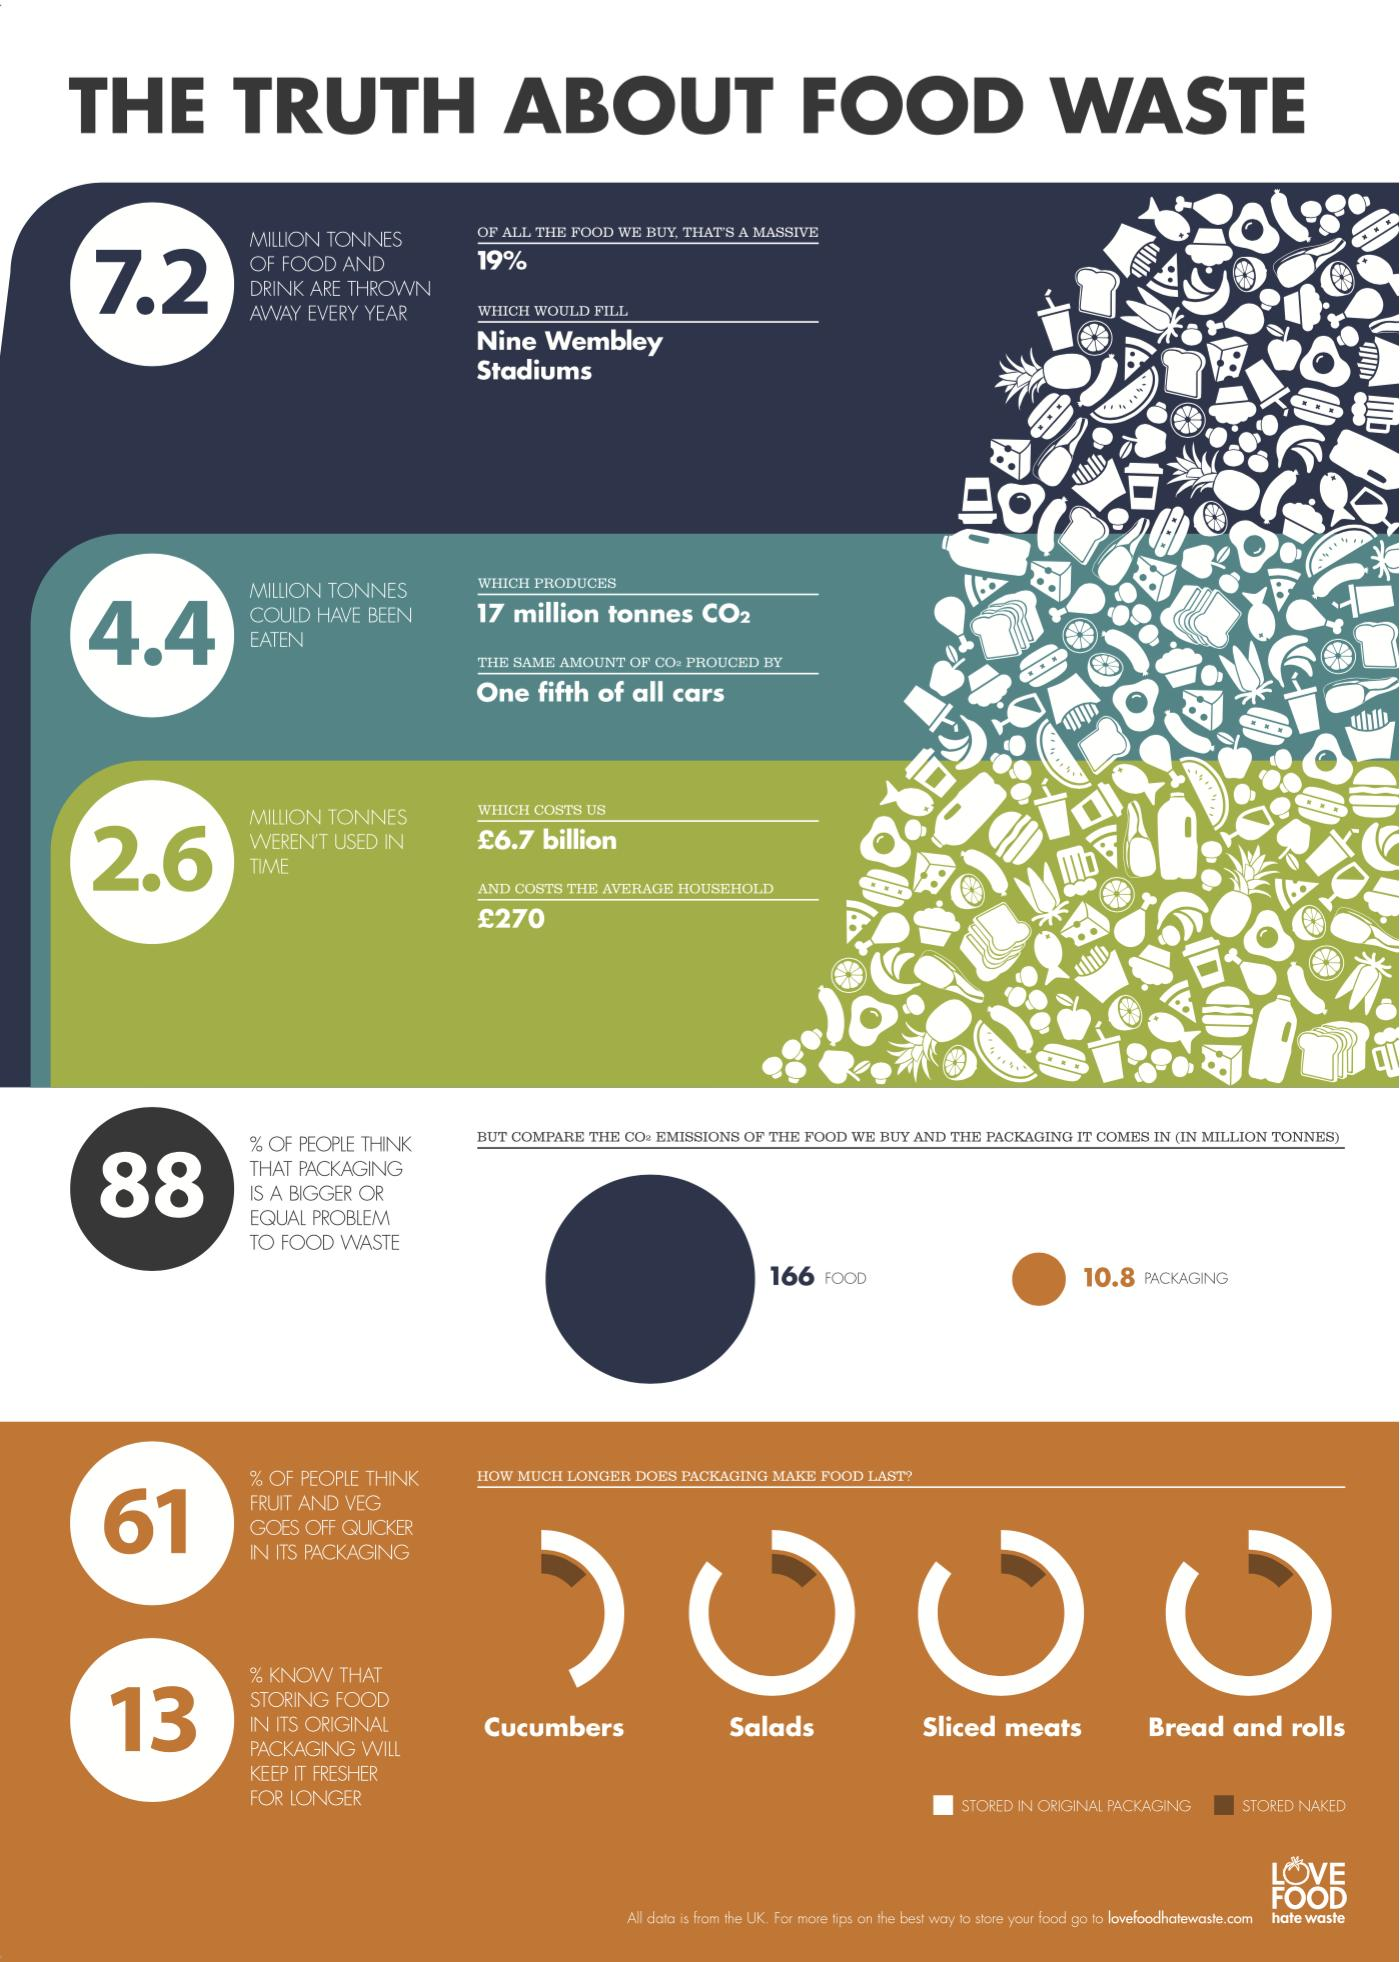Outline some significant characteristics in this image. According to a recent survey in the UK, an overwhelming 87% of people are unaware that storing food in its original packaging will help to keep it fresher for longer. According to a recent survey, only 12% of people in the UK believe that packaging is not a bigger or equal problem to food waste. 